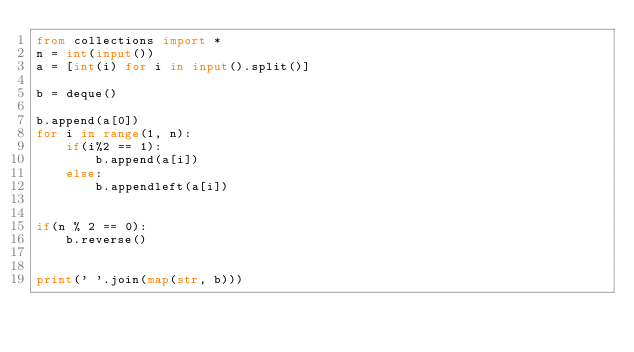Convert code to text. <code><loc_0><loc_0><loc_500><loc_500><_Python_>from collections import *
n = int(input())
a = [int(i) for i in input().split()]

b = deque()

b.append(a[0])
for i in range(1, n):
    if(i%2 == 1):
        b.append(a[i])  
    else:
        b.appendleft(a[i])
   

if(n % 2 == 0):
    b.reverse()
    

print(' '.join(map(str, b)))
</code> 